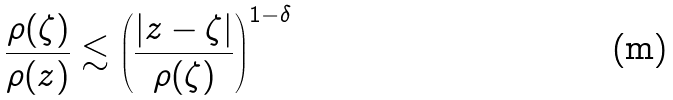<formula> <loc_0><loc_0><loc_500><loc_500>\frac { \rho ( \zeta ) } { \rho ( z ) } \lesssim \left ( \frac { | z - \zeta | } { \rho ( \zeta ) } \right ) ^ { 1 - \delta }</formula> 